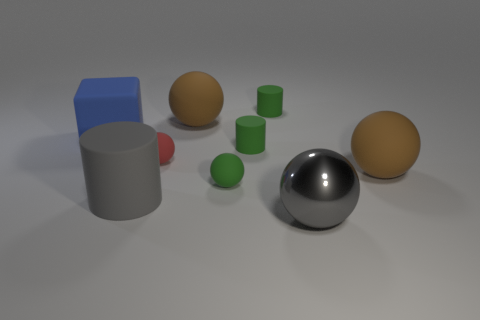Do the metallic thing and the red thing have the same shape?
Your response must be concise. Yes. How many gray objects are either balls or cylinders?
Provide a succinct answer. 2. Does the metal object that is right of the blue matte object have the same color as the big matte cylinder?
Make the answer very short. Yes. Is the large blue thing made of the same material as the green sphere?
Provide a succinct answer. Yes. Is the number of small cylinders that are in front of the shiny sphere the same as the number of large blue matte things that are to the left of the blue cube?
Offer a very short reply. Yes. There is a small green thing that is the same shape as the large gray metal object; what is its material?
Your response must be concise. Rubber. What shape is the large brown rubber thing that is left of the large ball to the right of the gray metallic object on the right side of the red ball?
Ensure brevity in your answer.  Sphere. Is the number of tiny objects that are to the right of the tiny red sphere greater than the number of large rubber cylinders?
Offer a terse response. Yes. Is the shape of the big brown object that is in front of the blue thing the same as  the big gray metal thing?
Keep it short and to the point. Yes. There is a large object that is left of the large matte cylinder; what is its material?
Your answer should be compact. Rubber. 